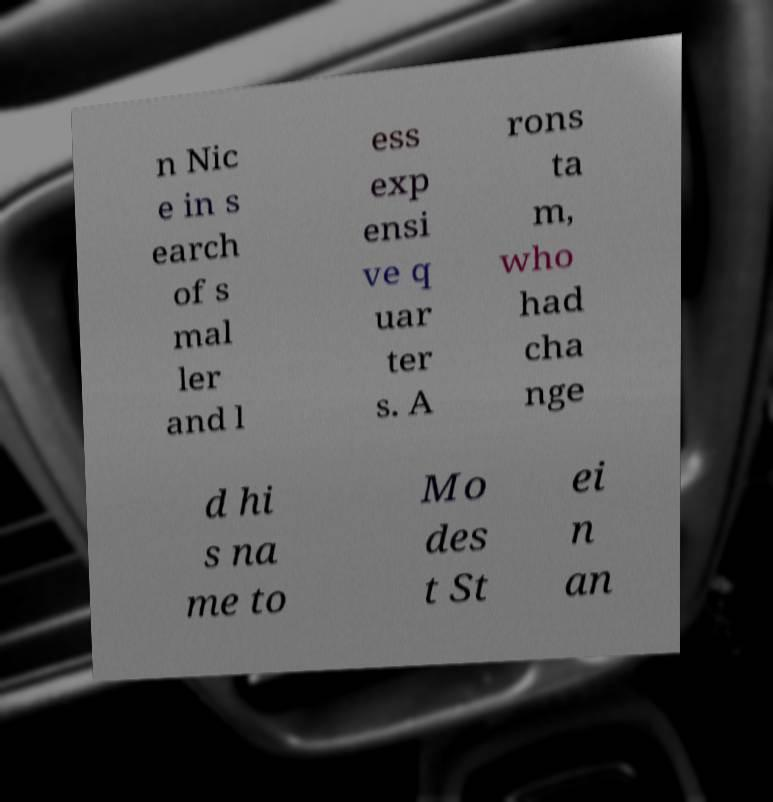Please read and relay the text visible in this image. What does it say? n Nic e in s earch of s mal ler and l ess exp ensi ve q uar ter s. A rons ta m, who had cha nge d hi s na me to Mo des t St ei n an 